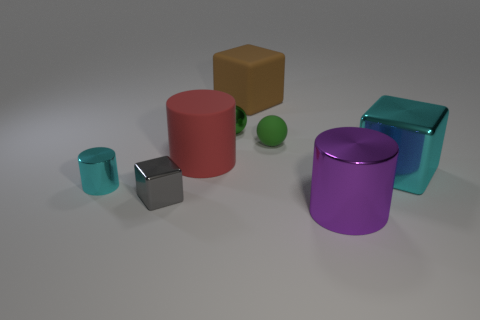How many tiny things are either shiny objects or brown matte things?
Your response must be concise. 3. What color is the matte sphere?
Make the answer very short. Green. What shape is the thing right of the metal cylinder right of the small green shiny sphere?
Give a very brief answer. Cube. Are there any big blue things made of the same material as the small gray cube?
Give a very brief answer. No. Do the cylinder right of the brown thing and the small gray metallic cube have the same size?
Make the answer very short. No. What number of cyan things are either big shiny objects or large matte things?
Give a very brief answer. 1. What is the material of the cylinder on the right side of the big brown matte block?
Your answer should be compact. Metal. There is a small green ball that is to the right of the green metal thing; what number of big blocks are in front of it?
Your response must be concise. 1. How many large rubber objects are the same shape as the purple shiny thing?
Your answer should be very brief. 1. What number of small brown spheres are there?
Provide a succinct answer. 0. 